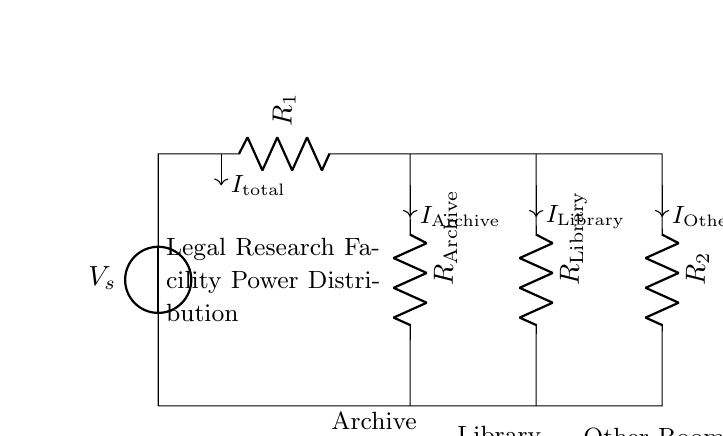What is the total current flowing through the circuit? The total current, indicated as I total, is the sum of the currents flowing through each individual branch. This current can be observed leaving the voltage source and entering the parallel resistors.
Answer: I total What are the values of the resistors? The resistors are labeled as R1, R2, R Archive, and R Library, but their numerical values are not specified in the diagram. However, you can refer to them generally by their roles as various rooms' loads.
Answer: R Archive, R Library, R1, R2 Which components represent power distribution to the Archive Room? The Archive Room is represented by the resistor labeled R Archive, which is connected to the second node from the voltage source. The current I Archive flows through this resistor specifically, indicating its load in the circuit.
Answer: R Archive How does the current divide among the different rooms? The current divides based on the resistance values of each component in parallel; higher resistance sees less current while lower resistance receives more. Each branch's current can be calculated using the formula I branch = V / R branch, where V is the voltage across the branch.
Answer: Based on resistance values What role does the voltage source play in this circuit? The voltage source provides the electrical energy needed to drive current through the resistive loads in the facility. It determines the potential difference across all components and is fundamental for the operation of the circuit.
Answer: Provides electrical energy What is the purpose of having multiple resistors for various rooms? Multiple resistors allow for individual control of current and power distribution to each room based on its usage requirements, promoting efficient electrical load management throughout the facility.
Answer: Individual current control 